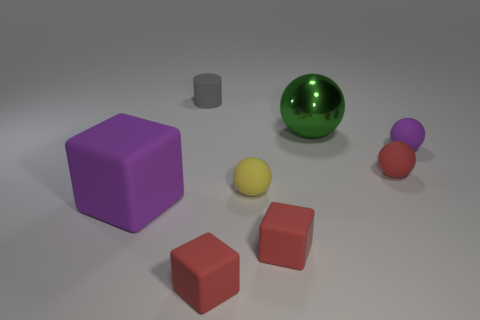What material is the small thing that is the same color as the large matte object?
Make the answer very short. Rubber. Is the size of the green metal object the same as the purple rubber object that is on the right side of the tiny matte cylinder?
Offer a terse response. No. Is there a big metal cylinder that has the same color as the tiny rubber cylinder?
Offer a terse response. No. Are there any tiny yellow objects that have the same shape as the green thing?
Make the answer very short. Yes. What shape is the small rubber thing that is in front of the yellow object and right of the yellow sphere?
Offer a terse response. Cube. What number of other small yellow spheres have the same material as the tiny yellow ball?
Give a very brief answer. 0. Are there fewer tiny red spheres behind the tiny gray cylinder than purple rubber things?
Make the answer very short. Yes. Is there a metal ball that is right of the purple object that is behind the yellow matte thing?
Your answer should be very brief. No. Are there any other things that have the same shape as the large purple rubber object?
Provide a succinct answer. Yes. Do the metal object and the rubber cylinder have the same size?
Offer a terse response. No. 